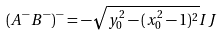Convert formula to latex. <formula><loc_0><loc_0><loc_500><loc_500>( A ^ { - } B ^ { - } ) ^ { - } = - \sqrt { y _ { 0 } ^ { 2 } - ( x _ { 0 } ^ { 2 } - 1 ) ^ { 2 } } I J</formula> 